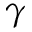Convert formula to latex. <formula><loc_0><loc_0><loc_500><loc_500>\gamma</formula> 